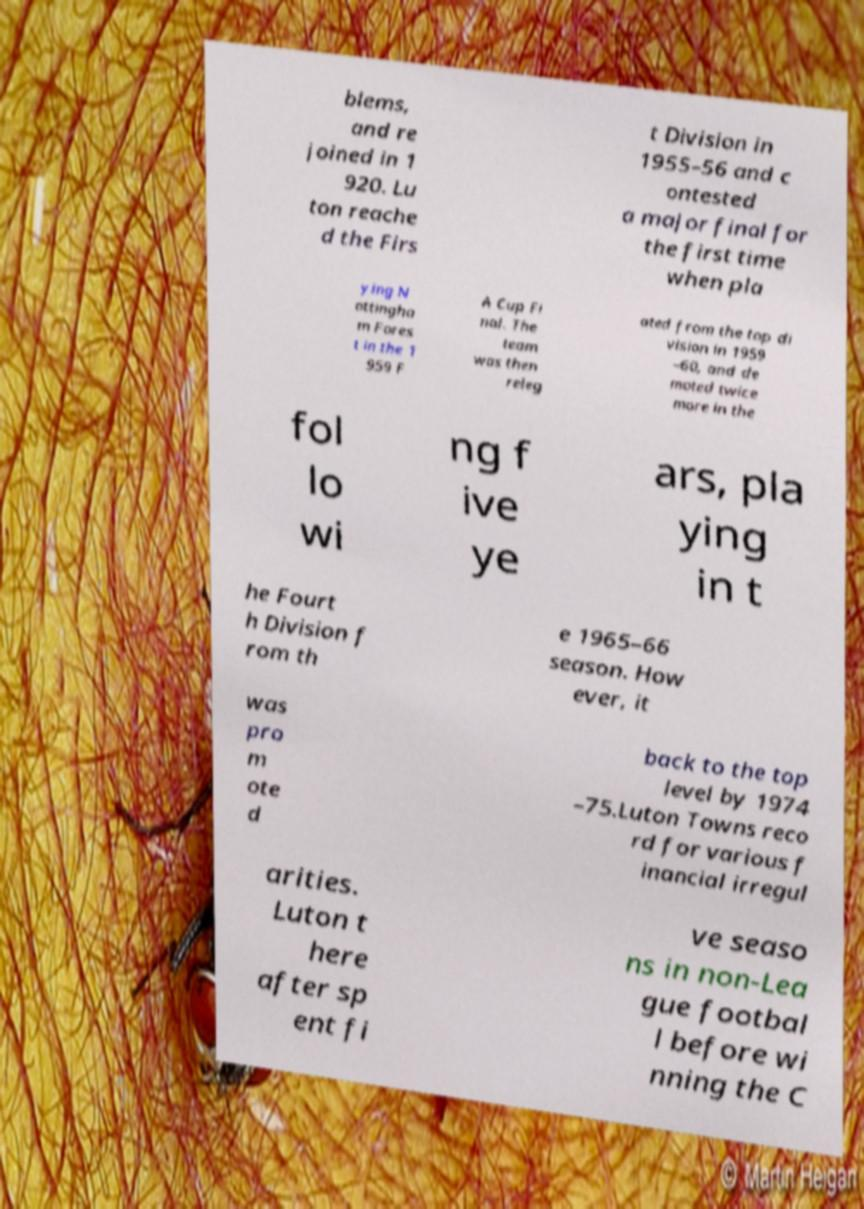Please read and relay the text visible in this image. What does it say? blems, and re joined in 1 920. Lu ton reache d the Firs t Division in 1955–56 and c ontested a major final for the first time when pla ying N ottingha m Fores t in the 1 959 F A Cup Fi nal. The team was then releg ated from the top di vision in 1959 –60, and de moted twice more in the fol lo wi ng f ive ye ars, pla ying in t he Fourt h Division f rom th e 1965–66 season. How ever, it was pro m ote d back to the top level by 1974 –75.Luton Towns reco rd for various f inancial irregul arities. Luton t here after sp ent fi ve seaso ns in non-Lea gue footbal l before wi nning the C 